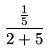<formula> <loc_0><loc_0><loc_500><loc_500>\frac { \frac { 1 } { 5 } } { 2 + 5 }</formula> 